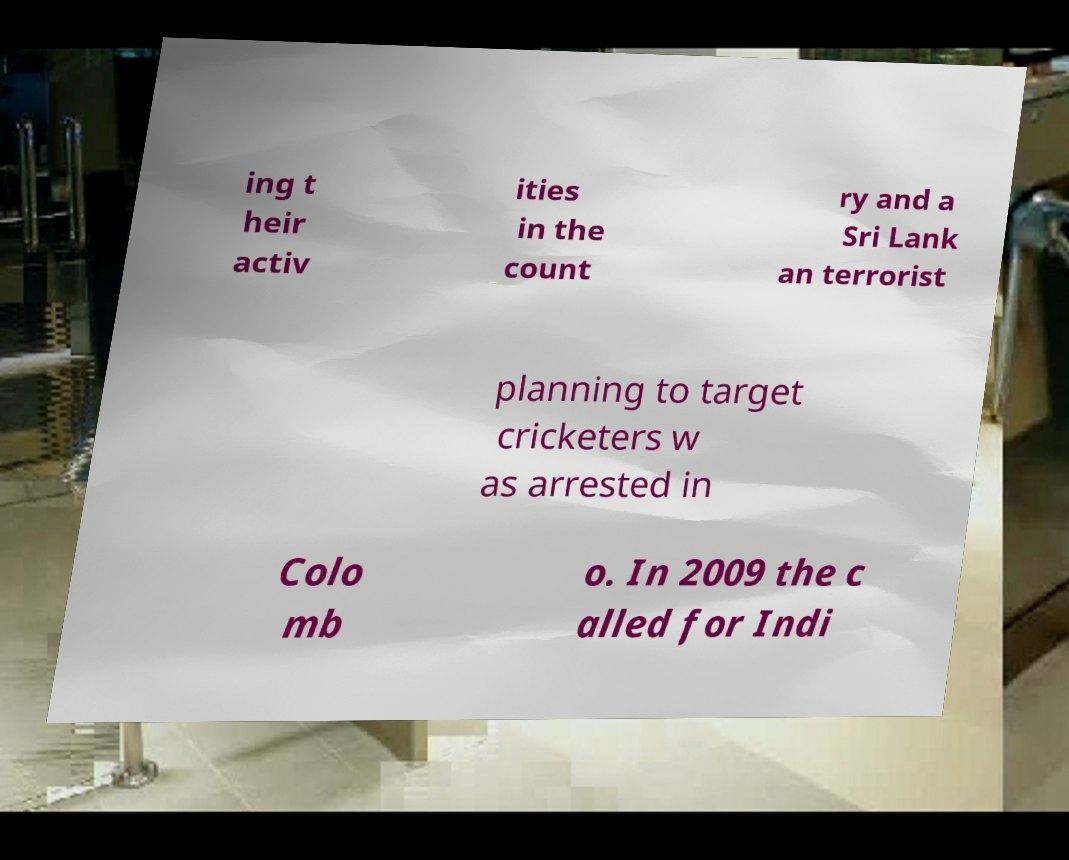Please identify and transcribe the text found in this image. ing t heir activ ities in the count ry and a Sri Lank an terrorist planning to target cricketers w as arrested in Colo mb o. In 2009 the c alled for Indi 